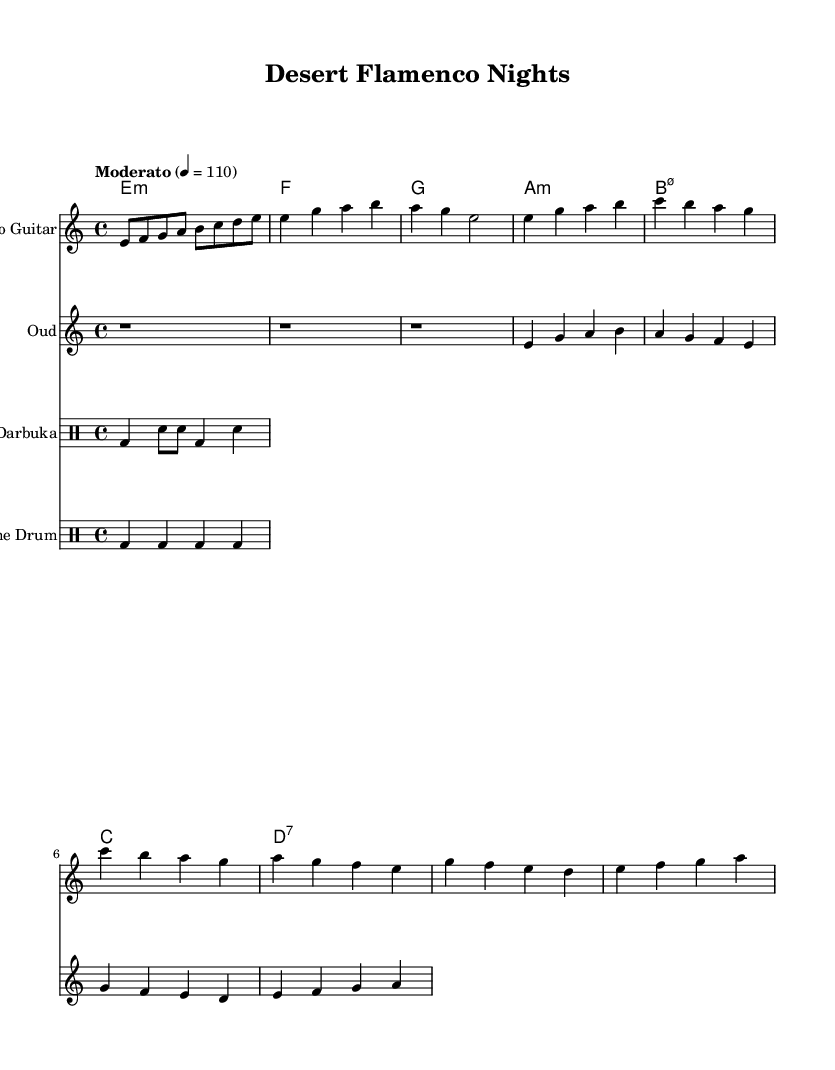What is the key signature of this music? The key signature indicated by the clef and the notes in the staff shows that the piece is in E Phrygian. E Phrygian has no sharps or flats, which is consistent with the absence of any accidentals in the score.
Answer: E Phrygian What is the time signature used in this piece? The time signature is located at the beginning of the score and is represented as 4/4, meaning there are four beats in each measure. This can be further confirmed by the rhythmic structure of the melody and accompaniment patterns throughout the piece.
Answer: 4/4 What is the tempo marking given in the score? The tempo marking can be found near the beginning of the score and indicates the speed of the piece. It states "Moderato," with a metronome indication of 110 beats per minute, which tells us to play at a moderate pace.
Answer: Moderato 4 = 110 What type of percussion is featured in the piece? The sheet indicates the presence of two types of percussion instruments: the darbuka and the frame drum. Each type has a designated staff in the score, and their specific sections denote their respective rhythmic patterns.
Answer: Darbuka and frame drum Which instrument plays the main melody in the verses? In the provided score, the flamenco guitar plays the main melody during the verses, as indicated by the designated staff for that instrument and the melodic lines composed above. The oud serves more as a harmonic support.
Answer: Flamenco guitar How many bars are in the chorus section? To determine the number of bars in the chorus section, we can look at the scored measures specifically marked as the chorus. By counting the measures indicated after the verse transitional sections, we find that the chorus contains a total of four measures.
Answer: Four bars What is the harmonic progression in the piece? The harmonic progression can be understood from the chord names provided below the staff lines. Analyzing the chord structure reveals a sequence: E minor, F major, G major, A minor, B minor seventh flat five, C major, and D seventh. This outlines the harmonic foundation throughout the piece.
Answer: E minor, F, G, A minor, B minor seventh flat five, C, D seventh 